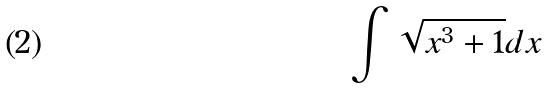Convert formula to latex. <formula><loc_0><loc_0><loc_500><loc_500>\int \sqrt { x ^ { 3 } + 1 } d x</formula> 